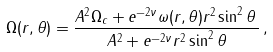<formula> <loc_0><loc_0><loc_500><loc_500>\Omega ( r , \theta ) = \frac { A ^ { 2 } \Omega _ { c } + e ^ { - 2 \nu } \omega ( r , \theta ) r ^ { 2 } \sin ^ { 2 } \theta \, } { A ^ { 2 } + e ^ { - 2 \nu } r ^ { 2 } \sin ^ { 2 } \theta } \, ,</formula> 